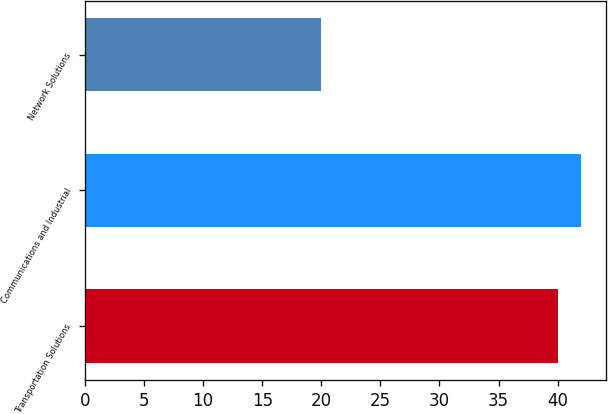Convert chart to OTSL. <chart><loc_0><loc_0><loc_500><loc_500><bar_chart><fcel>Transportation Solutions<fcel>Communications and Industrial<fcel>Network Solutions<nl><fcel>40<fcel>42<fcel>20<nl></chart> 